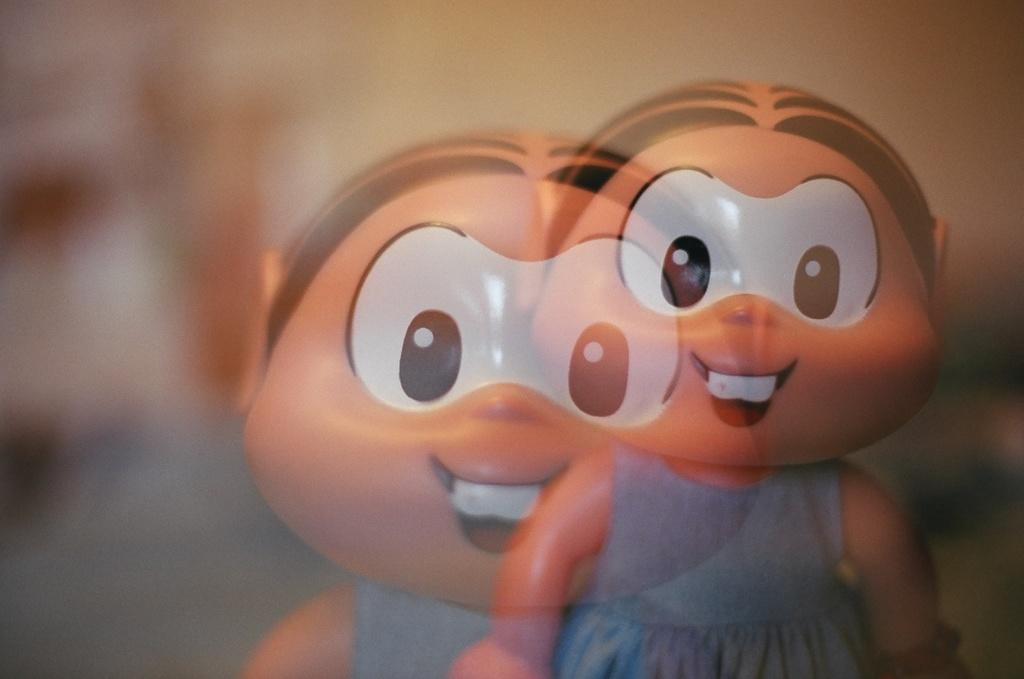What is the main subject in the image? There is a toy in the image. What color is the dress that the toy is wearing? The toy is wearing a blue color dress. Can you describe the background of the image? The background of the image is blurred. What type of action is taking place in the lunchroom in the image? There is no lunchroom present in the image, and therefore no action taking place in a lunchroom. What type of glass object can be seen in the image? There is no glass object present in the image. 